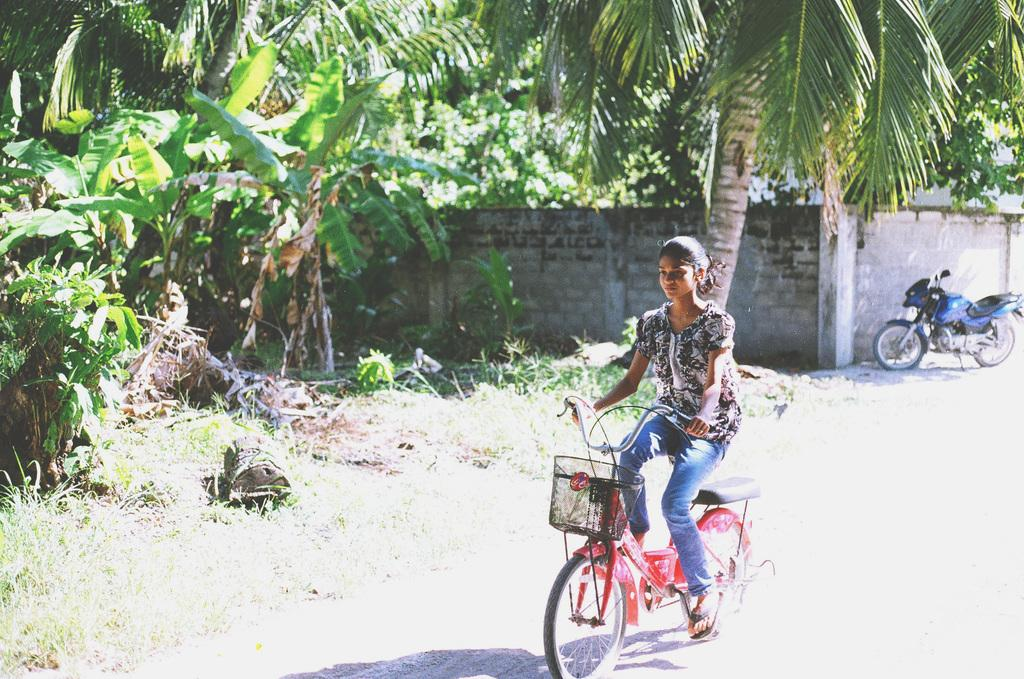What is the girl doing in the image? The girl is riding a bicycle in the image. Can you describe the setting of the image? There is a bike in front of a wall in the image, and there are coconut and banana trees on the ground. What type of trees can be seen in the image? Coconut and banana trees are visible in the image. What type of coat is the fireman wearing in the image? There is no fireman or coat present in the image. How does the beggar interact with the girl riding the bicycle in the image? There is no beggar present in the image; the girl is riding the bicycle alone. 